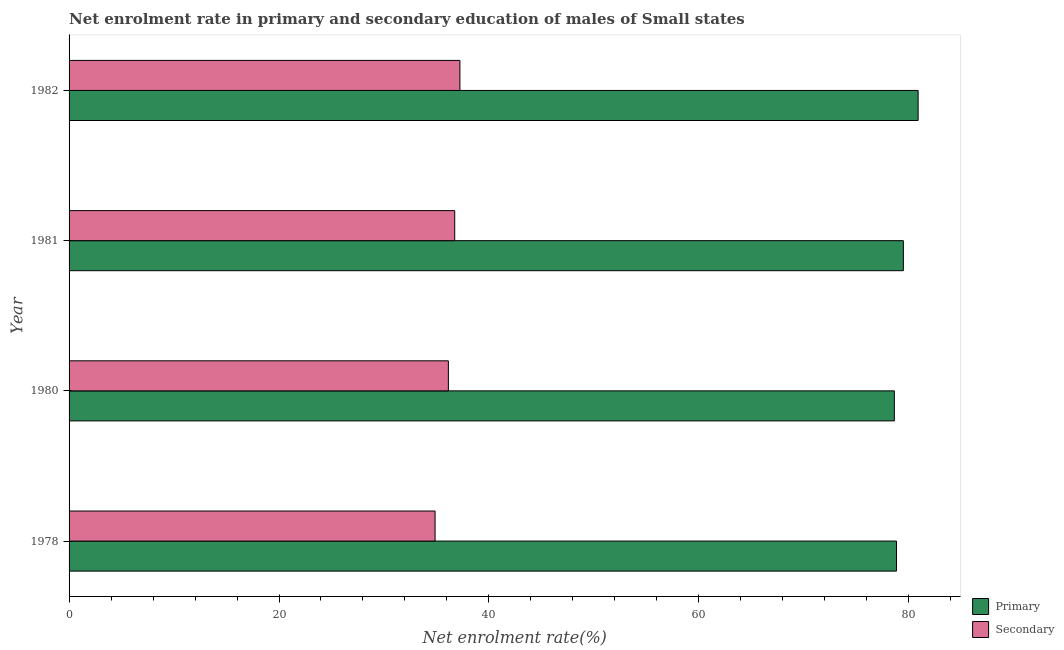How many bars are there on the 1st tick from the top?
Your response must be concise. 2. What is the label of the 4th group of bars from the top?
Offer a terse response. 1978. What is the enrollment rate in secondary education in 1981?
Your response must be concise. 36.74. Across all years, what is the maximum enrollment rate in primary education?
Offer a very short reply. 80.89. Across all years, what is the minimum enrollment rate in secondary education?
Your response must be concise. 34.87. In which year was the enrollment rate in primary education minimum?
Provide a short and direct response. 1980. What is the total enrollment rate in primary education in the graph?
Make the answer very short. 317.84. What is the difference between the enrollment rate in secondary education in 1978 and that in 1981?
Your answer should be very brief. -1.87. What is the difference between the enrollment rate in primary education in 1978 and the enrollment rate in secondary education in 1980?
Provide a short and direct response. 42.7. What is the average enrollment rate in primary education per year?
Keep it short and to the point. 79.46. In the year 1978, what is the difference between the enrollment rate in primary education and enrollment rate in secondary education?
Offer a terse response. 43.96. In how many years, is the enrollment rate in primary education greater than 4 %?
Give a very brief answer. 4. Is the enrollment rate in secondary education in 1978 less than that in 1980?
Your answer should be compact. Yes. What is the difference between the highest and the second highest enrollment rate in primary education?
Make the answer very short. 1.41. What is the difference between the highest and the lowest enrollment rate in secondary education?
Give a very brief answer. 2.37. What does the 1st bar from the top in 1980 represents?
Ensure brevity in your answer.  Secondary. What does the 2nd bar from the bottom in 1982 represents?
Your answer should be compact. Secondary. How many bars are there?
Your answer should be very brief. 8. Are all the bars in the graph horizontal?
Give a very brief answer. Yes. Does the graph contain any zero values?
Ensure brevity in your answer.  No. Does the graph contain grids?
Offer a terse response. No. Where does the legend appear in the graph?
Ensure brevity in your answer.  Bottom right. How are the legend labels stacked?
Your answer should be compact. Vertical. What is the title of the graph?
Make the answer very short. Net enrolment rate in primary and secondary education of males of Small states. Does "RDB concessional" appear as one of the legend labels in the graph?
Give a very brief answer. No. What is the label or title of the X-axis?
Your answer should be compact. Net enrolment rate(%). What is the label or title of the Y-axis?
Your response must be concise. Year. What is the Net enrolment rate(%) of Primary in 1978?
Your answer should be very brief. 78.83. What is the Net enrolment rate(%) of Secondary in 1978?
Provide a short and direct response. 34.87. What is the Net enrolment rate(%) of Primary in 1980?
Keep it short and to the point. 78.63. What is the Net enrolment rate(%) of Secondary in 1980?
Offer a very short reply. 36.14. What is the Net enrolment rate(%) of Primary in 1981?
Provide a succinct answer. 79.49. What is the Net enrolment rate(%) in Secondary in 1981?
Provide a succinct answer. 36.74. What is the Net enrolment rate(%) in Primary in 1982?
Provide a succinct answer. 80.89. What is the Net enrolment rate(%) in Secondary in 1982?
Make the answer very short. 37.24. Across all years, what is the maximum Net enrolment rate(%) of Primary?
Ensure brevity in your answer.  80.89. Across all years, what is the maximum Net enrolment rate(%) in Secondary?
Ensure brevity in your answer.  37.24. Across all years, what is the minimum Net enrolment rate(%) of Primary?
Your answer should be very brief. 78.63. Across all years, what is the minimum Net enrolment rate(%) in Secondary?
Offer a terse response. 34.87. What is the total Net enrolment rate(%) of Primary in the graph?
Make the answer very short. 317.84. What is the total Net enrolment rate(%) of Secondary in the graph?
Your answer should be compact. 144.98. What is the difference between the Net enrolment rate(%) in Primary in 1978 and that in 1980?
Make the answer very short. 0.21. What is the difference between the Net enrolment rate(%) in Secondary in 1978 and that in 1980?
Your response must be concise. -1.27. What is the difference between the Net enrolment rate(%) in Primary in 1978 and that in 1981?
Offer a very short reply. -0.65. What is the difference between the Net enrolment rate(%) of Secondary in 1978 and that in 1981?
Give a very brief answer. -1.87. What is the difference between the Net enrolment rate(%) of Primary in 1978 and that in 1982?
Make the answer very short. -2.06. What is the difference between the Net enrolment rate(%) of Secondary in 1978 and that in 1982?
Your answer should be very brief. -2.37. What is the difference between the Net enrolment rate(%) of Primary in 1980 and that in 1981?
Your answer should be very brief. -0.86. What is the difference between the Net enrolment rate(%) of Secondary in 1980 and that in 1981?
Your response must be concise. -0.6. What is the difference between the Net enrolment rate(%) in Primary in 1980 and that in 1982?
Your answer should be compact. -2.27. What is the difference between the Net enrolment rate(%) of Secondary in 1980 and that in 1982?
Give a very brief answer. -1.1. What is the difference between the Net enrolment rate(%) in Primary in 1981 and that in 1982?
Offer a terse response. -1.41. What is the difference between the Net enrolment rate(%) of Secondary in 1981 and that in 1982?
Your response must be concise. -0.49. What is the difference between the Net enrolment rate(%) of Primary in 1978 and the Net enrolment rate(%) of Secondary in 1980?
Provide a short and direct response. 42.7. What is the difference between the Net enrolment rate(%) of Primary in 1978 and the Net enrolment rate(%) of Secondary in 1981?
Make the answer very short. 42.09. What is the difference between the Net enrolment rate(%) of Primary in 1978 and the Net enrolment rate(%) of Secondary in 1982?
Your response must be concise. 41.6. What is the difference between the Net enrolment rate(%) in Primary in 1980 and the Net enrolment rate(%) in Secondary in 1981?
Your answer should be compact. 41.88. What is the difference between the Net enrolment rate(%) in Primary in 1980 and the Net enrolment rate(%) in Secondary in 1982?
Give a very brief answer. 41.39. What is the difference between the Net enrolment rate(%) of Primary in 1981 and the Net enrolment rate(%) of Secondary in 1982?
Your response must be concise. 42.25. What is the average Net enrolment rate(%) in Primary per year?
Offer a terse response. 79.46. What is the average Net enrolment rate(%) in Secondary per year?
Give a very brief answer. 36.25. In the year 1978, what is the difference between the Net enrolment rate(%) of Primary and Net enrolment rate(%) of Secondary?
Provide a short and direct response. 43.96. In the year 1980, what is the difference between the Net enrolment rate(%) in Primary and Net enrolment rate(%) in Secondary?
Ensure brevity in your answer.  42.49. In the year 1981, what is the difference between the Net enrolment rate(%) of Primary and Net enrolment rate(%) of Secondary?
Your answer should be very brief. 42.74. In the year 1982, what is the difference between the Net enrolment rate(%) of Primary and Net enrolment rate(%) of Secondary?
Your answer should be very brief. 43.66. What is the ratio of the Net enrolment rate(%) in Primary in 1978 to that in 1980?
Keep it short and to the point. 1. What is the ratio of the Net enrolment rate(%) of Secondary in 1978 to that in 1980?
Your response must be concise. 0.96. What is the ratio of the Net enrolment rate(%) in Primary in 1978 to that in 1981?
Make the answer very short. 0.99. What is the ratio of the Net enrolment rate(%) of Secondary in 1978 to that in 1981?
Provide a short and direct response. 0.95. What is the ratio of the Net enrolment rate(%) in Primary in 1978 to that in 1982?
Your answer should be very brief. 0.97. What is the ratio of the Net enrolment rate(%) of Secondary in 1978 to that in 1982?
Give a very brief answer. 0.94. What is the ratio of the Net enrolment rate(%) of Primary in 1980 to that in 1981?
Provide a succinct answer. 0.99. What is the ratio of the Net enrolment rate(%) in Secondary in 1980 to that in 1981?
Provide a short and direct response. 0.98. What is the ratio of the Net enrolment rate(%) in Primary in 1980 to that in 1982?
Your answer should be compact. 0.97. What is the ratio of the Net enrolment rate(%) in Secondary in 1980 to that in 1982?
Make the answer very short. 0.97. What is the ratio of the Net enrolment rate(%) in Primary in 1981 to that in 1982?
Offer a very short reply. 0.98. What is the ratio of the Net enrolment rate(%) in Secondary in 1981 to that in 1982?
Make the answer very short. 0.99. What is the difference between the highest and the second highest Net enrolment rate(%) of Primary?
Offer a very short reply. 1.41. What is the difference between the highest and the second highest Net enrolment rate(%) of Secondary?
Your answer should be compact. 0.49. What is the difference between the highest and the lowest Net enrolment rate(%) in Primary?
Ensure brevity in your answer.  2.27. What is the difference between the highest and the lowest Net enrolment rate(%) in Secondary?
Give a very brief answer. 2.37. 